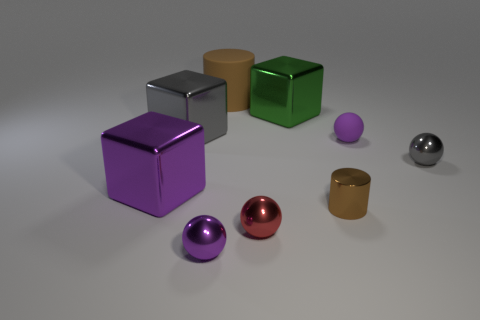Are there any other things that are the same material as the large purple thing?
Ensure brevity in your answer.  Yes. There is another small rubber object that is the same shape as the tiny red object; what is its color?
Ensure brevity in your answer.  Purple. What number of objects are either green blocks or large metallic cylinders?
Your answer should be very brief. 1. What is the shape of the brown thing that is the same material as the green thing?
Your response must be concise. Cylinder. How many big objects are green metal blocks or matte cylinders?
Keep it short and to the point. 2. How many other things are there of the same color as the small rubber thing?
Your answer should be compact. 2. How many spheres are in front of the small rubber thing that is behind the cylinder that is in front of the big gray cube?
Your response must be concise. 3. Do the cylinder behind the gray ball and the tiny brown metal cylinder have the same size?
Keep it short and to the point. No. Are there fewer small purple things that are in front of the tiny gray metallic thing than small things that are right of the tiny red ball?
Your response must be concise. Yes. Is the color of the big matte thing the same as the metallic cylinder?
Your answer should be compact. Yes. 